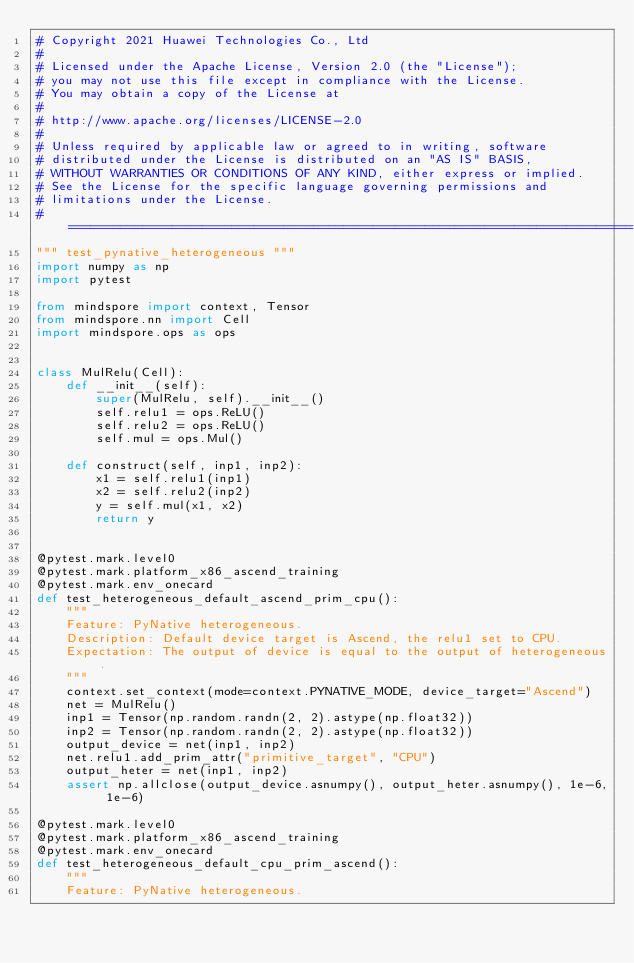Convert code to text. <code><loc_0><loc_0><loc_500><loc_500><_Python_># Copyright 2021 Huawei Technologies Co., Ltd
#
# Licensed under the Apache License, Version 2.0 (the "License");
# you may not use this file except in compliance with the License.
# You may obtain a copy of the License at
#
# http://www.apache.org/licenses/LICENSE-2.0
#
# Unless required by applicable law or agreed to in writing, software
# distributed under the License is distributed on an "AS IS" BASIS,
# WITHOUT WARRANTIES OR CONDITIONS OF ANY KIND, either express or implied.
# See the License for the specific language governing permissions and
# limitations under the License.
# ============================================================================
""" test_pynative_heterogeneous """
import numpy as np
import pytest

from mindspore import context, Tensor
from mindspore.nn import Cell
import mindspore.ops as ops


class MulRelu(Cell):
    def __init__(self):
        super(MulRelu, self).__init__()
        self.relu1 = ops.ReLU()
        self.relu2 = ops.ReLU()
        self.mul = ops.Mul()

    def construct(self, inp1, inp2):
        x1 = self.relu1(inp1)
        x2 = self.relu2(inp2)
        y = self.mul(x1, x2)
        return y


@pytest.mark.level0
@pytest.mark.platform_x86_ascend_training
@pytest.mark.env_onecard
def test_heterogeneous_default_ascend_prim_cpu():
    """
    Feature: PyNative heterogeneous.
    Description: Default device target is Ascend, the relu1 set to CPU.
    Expectation: The output of device is equal to the output of heterogeneous.
    """
    context.set_context(mode=context.PYNATIVE_MODE, device_target="Ascend")
    net = MulRelu()
    inp1 = Tensor(np.random.randn(2, 2).astype(np.float32))
    inp2 = Tensor(np.random.randn(2, 2).astype(np.float32))
    output_device = net(inp1, inp2)
    net.relu1.add_prim_attr("primitive_target", "CPU")
    output_heter = net(inp1, inp2)
    assert np.allclose(output_device.asnumpy(), output_heter.asnumpy(), 1e-6, 1e-6)

@pytest.mark.level0
@pytest.mark.platform_x86_ascend_training
@pytest.mark.env_onecard
def test_heterogeneous_default_cpu_prim_ascend():
    """
    Feature: PyNative heterogeneous.</code> 